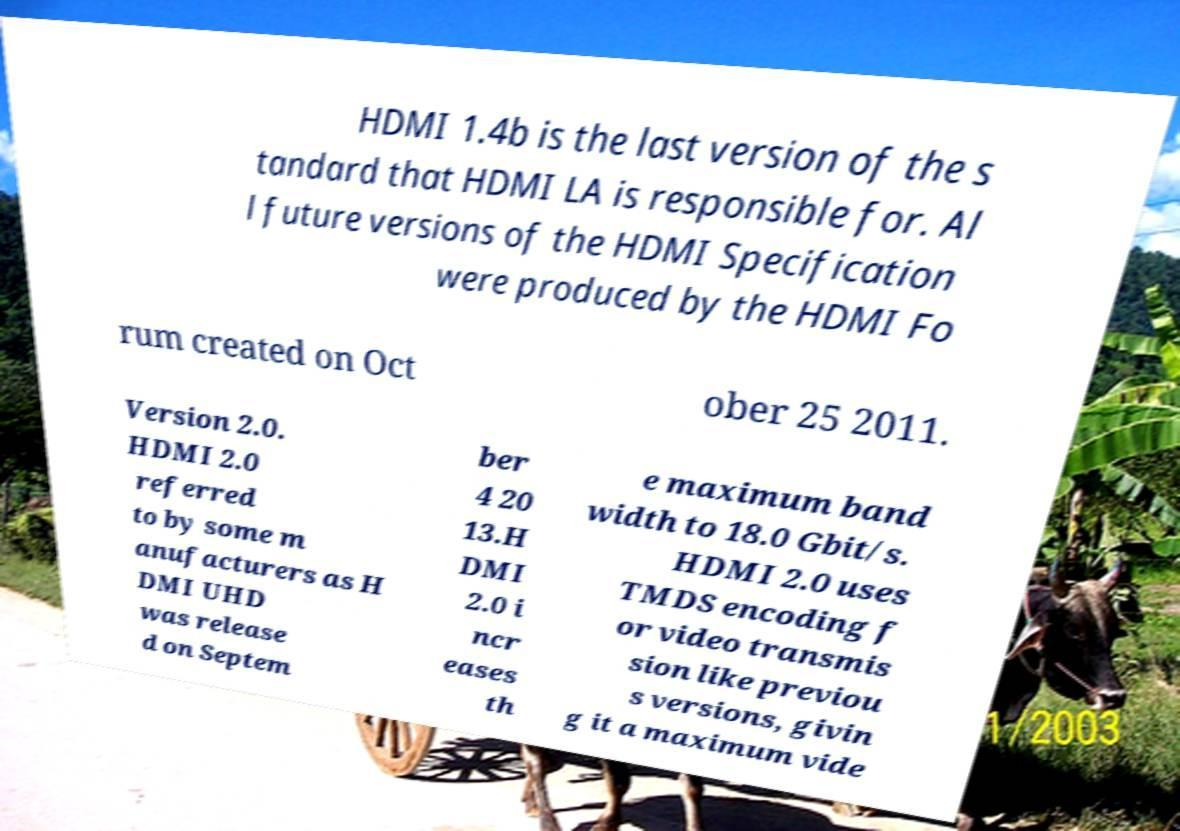Can you accurately transcribe the text from the provided image for me? HDMI 1.4b is the last version of the s tandard that HDMI LA is responsible for. Al l future versions of the HDMI Specification were produced by the HDMI Fo rum created on Oct ober 25 2011. Version 2.0. HDMI 2.0 referred to by some m anufacturers as H DMI UHD was release d on Septem ber 4 20 13.H DMI 2.0 i ncr eases th e maximum band width to 18.0 Gbit/s. HDMI 2.0 uses TMDS encoding f or video transmis sion like previou s versions, givin g it a maximum vide 